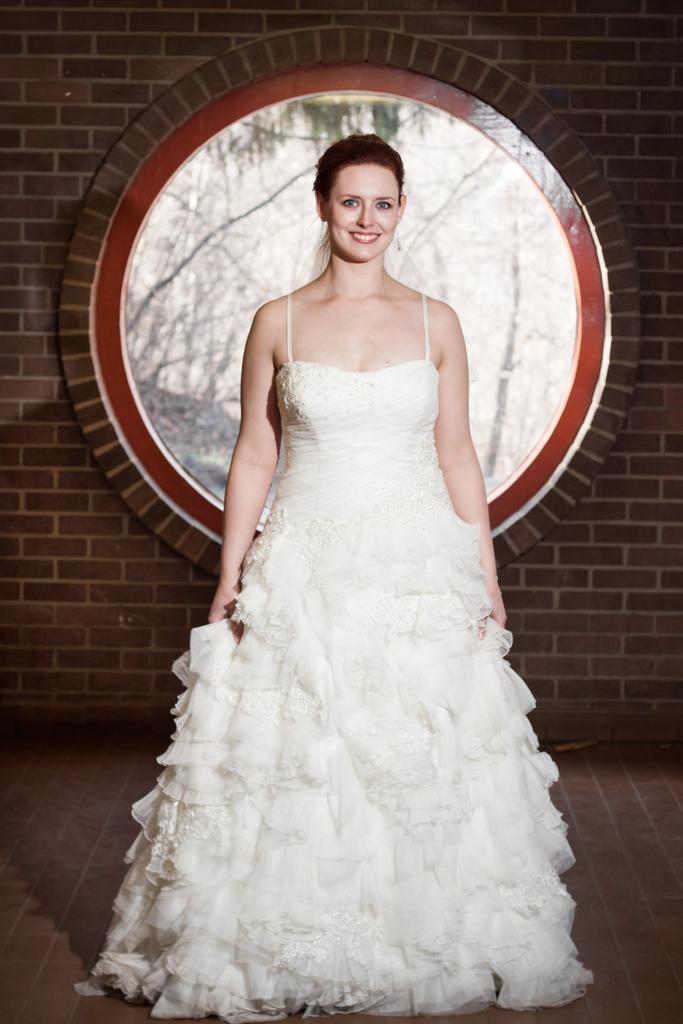Can you describe this image briefly? In this picture, we see a woman in the white dress is stunning. She is smiling and she might be posing for the photo. In the background, we see a wall which is made up of bricks. Behind her, we see a glass from which we can see the trees. At the bottom, we see the floor. 